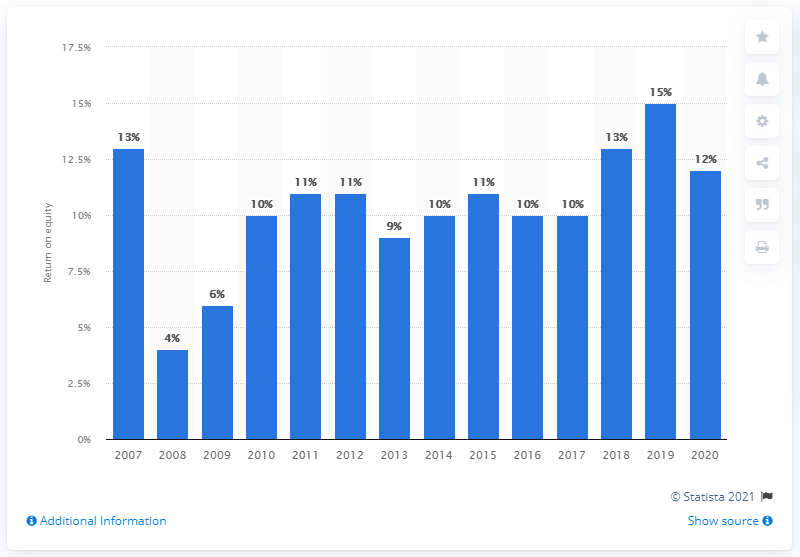Highlight a few significant elements in this photo. JPMorgan Chase's return on common equity in 2020 was 12%. 